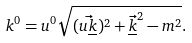Convert formula to latex. <formula><loc_0><loc_0><loc_500><loc_500>k ^ { 0 } = u ^ { 0 } \sqrt { ( \vec { u \underline { k } } ) ^ { 2 } + \vec { \underline { k } } ^ { 2 } - m ^ { 2 } } .</formula> 